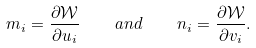<formula> <loc_0><loc_0><loc_500><loc_500>m _ { i } = \frac { \partial \mathcal { W } } { \partial u _ { i } } \quad a n d \quad n _ { i } = \frac { \partial \mathcal { W } } { \partial v _ { i } } .</formula> 